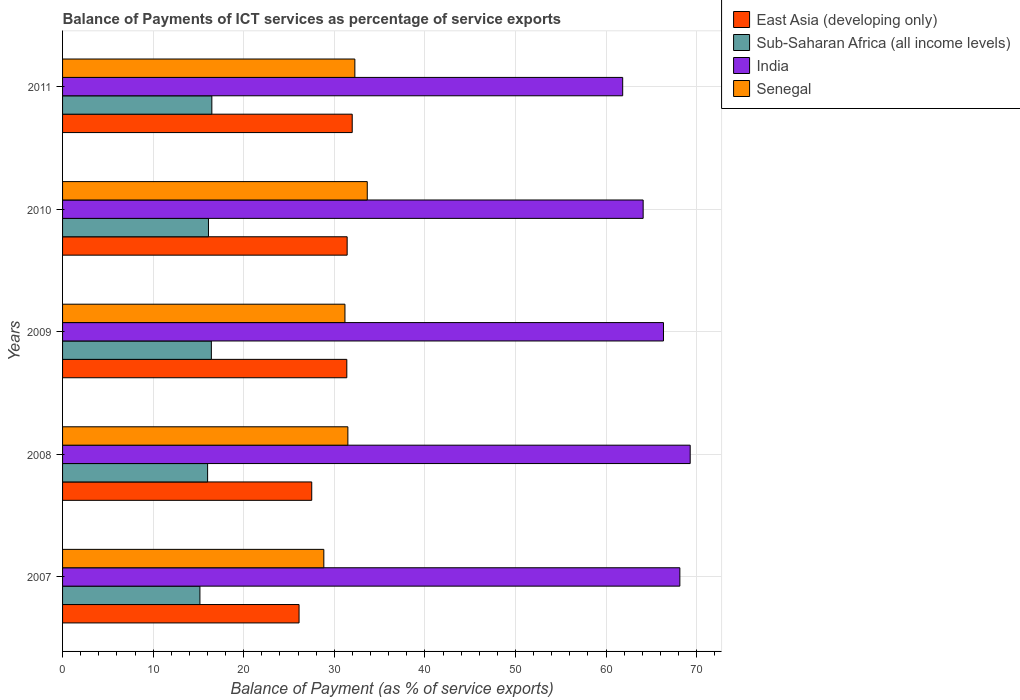How many different coloured bars are there?
Provide a succinct answer. 4. Are the number of bars per tick equal to the number of legend labels?
Offer a very short reply. Yes. How many bars are there on the 2nd tick from the top?
Provide a succinct answer. 4. What is the balance of payments of ICT services in East Asia (developing only) in 2007?
Keep it short and to the point. 26.11. Across all years, what is the maximum balance of payments of ICT services in India?
Your answer should be very brief. 69.29. Across all years, what is the minimum balance of payments of ICT services in East Asia (developing only)?
Provide a succinct answer. 26.11. In which year was the balance of payments of ICT services in India maximum?
Provide a short and direct response. 2008. What is the total balance of payments of ICT services in Sub-Saharan Africa (all income levels) in the graph?
Ensure brevity in your answer.  80.19. What is the difference between the balance of payments of ICT services in Senegal in 2008 and that in 2011?
Provide a succinct answer. -0.77. What is the difference between the balance of payments of ICT services in Sub-Saharan Africa (all income levels) in 2010 and the balance of payments of ICT services in India in 2009?
Ensure brevity in your answer.  -50.23. What is the average balance of payments of ICT services in Senegal per year?
Your answer should be very brief. 31.49. In the year 2011, what is the difference between the balance of payments of ICT services in India and balance of payments of ICT services in Sub-Saharan Africa (all income levels)?
Ensure brevity in your answer.  45.36. In how many years, is the balance of payments of ICT services in Senegal greater than 40 %?
Your answer should be compact. 0. What is the ratio of the balance of payments of ICT services in East Asia (developing only) in 2007 to that in 2011?
Provide a succinct answer. 0.82. Is the balance of payments of ICT services in Senegal in 2007 less than that in 2009?
Offer a very short reply. Yes. What is the difference between the highest and the second highest balance of payments of ICT services in Senegal?
Ensure brevity in your answer.  1.37. What is the difference between the highest and the lowest balance of payments of ICT services in Senegal?
Provide a succinct answer. 4.8. Is the sum of the balance of payments of ICT services in India in 2007 and 2010 greater than the maximum balance of payments of ICT services in Sub-Saharan Africa (all income levels) across all years?
Give a very brief answer. Yes. What does the 4th bar from the top in 2010 represents?
Ensure brevity in your answer.  East Asia (developing only). What does the 1st bar from the bottom in 2011 represents?
Provide a short and direct response. East Asia (developing only). Is it the case that in every year, the sum of the balance of payments of ICT services in Senegal and balance of payments of ICT services in East Asia (developing only) is greater than the balance of payments of ICT services in India?
Offer a terse response. No. How many years are there in the graph?
Provide a succinct answer. 5. Are the values on the major ticks of X-axis written in scientific E-notation?
Offer a terse response. No. Where does the legend appear in the graph?
Keep it short and to the point. Top right. How are the legend labels stacked?
Your answer should be compact. Vertical. What is the title of the graph?
Provide a succinct answer. Balance of Payments of ICT services as percentage of service exports. What is the label or title of the X-axis?
Your response must be concise. Balance of Payment (as % of service exports). What is the Balance of Payment (as % of service exports) of East Asia (developing only) in 2007?
Provide a succinct answer. 26.11. What is the Balance of Payment (as % of service exports) in Sub-Saharan Africa (all income levels) in 2007?
Keep it short and to the point. 15.16. What is the Balance of Payment (as % of service exports) of India in 2007?
Ensure brevity in your answer.  68.15. What is the Balance of Payment (as % of service exports) in Senegal in 2007?
Keep it short and to the point. 28.84. What is the Balance of Payment (as % of service exports) of East Asia (developing only) in 2008?
Your response must be concise. 27.51. What is the Balance of Payment (as % of service exports) in Sub-Saharan Africa (all income levels) in 2008?
Your answer should be compact. 16.01. What is the Balance of Payment (as % of service exports) in India in 2008?
Offer a very short reply. 69.29. What is the Balance of Payment (as % of service exports) of Senegal in 2008?
Offer a terse response. 31.5. What is the Balance of Payment (as % of service exports) of East Asia (developing only) in 2009?
Give a very brief answer. 31.38. What is the Balance of Payment (as % of service exports) of Sub-Saharan Africa (all income levels) in 2009?
Provide a succinct answer. 16.43. What is the Balance of Payment (as % of service exports) of India in 2009?
Provide a short and direct response. 66.34. What is the Balance of Payment (as % of service exports) in Senegal in 2009?
Ensure brevity in your answer.  31.18. What is the Balance of Payment (as % of service exports) in East Asia (developing only) in 2010?
Provide a short and direct response. 31.42. What is the Balance of Payment (as % of service exports) of Sub-Saharan Africa (all income levels) in 2010?
Ensure brevity in your answer.  16.11. What is the Balance of Payment (as % of service exports) of India in 2010?
Your answer should be compact. 64.1. What is the Balance of Payment (as % of service exports) in Senegal in 2010?
Keep it short and to the point. 33.64. What is the Balance of Payment (as % of service exports) of East Asia (developing only) in 2011?
Ensure brevity in your answer.  31.98. What is the Balance of Payment (as % of service exports) in Sub-Saharan Africa (all income levels) in 2011?
Make the answer very short. 16.48. What is the Balance of Payment (as % of service exports) of India in 2011?
Your answer should be compact. 61.84. What is the Balance of Payment (as % of service exports) in Senegal in 2011?
Your answer should be very brief. 32.27. Across all years, what is the maximum Balance of Payment (as % of service exports) in East Asia (developing only)?
Make the answer very short. 31.98. Across all years, what is the maximum Balance of Payment (as % of service exports) of Sub-Saharan Africa (all income levels)?
Your response must be concise. 16.48. Across all years, what is the maximum Balance of Payment (as % of service exports) of India?
Make the answer very short. 69.29. Across all years, what is the maximum Balance of Payment (as % of service exports) of Senegal?
Provide a succinct answer. 33.64. Across all years, what is the minimum Balance of Payment (as % of service exports) in East Asia (developing only)?
Provide a short and direct response. 26.11. Across all years, what is the minimum Balance of Payment (as % of service exports) in Sub-Saharan Africa (all income levels)?
Offer a terse response. 15.16. Across all years, what is the minimum Balance of Payment (as % of service exports) in India?
Keep it short and to the point. 61.84. Across all years, what is the minimum Balance of Payment (as % of service exports) in Senegal?
Keep it short and to the point. 28.84. What is the total Balance of Payment (as % of service exports) in East Asia (developing only) in the graph?
Your answer should be compact. 148.39. What is the total Balance of Payment (as % of service exports) of Sub-Saharan Africa (all income levels) in the graph?
Ensure brevity in your answer.  80.19. What is the total Balance of Payment (as % of service exports) of India in the graph?
Offer a very short reply. 329.72. What is the total Balance of Payment (as % of service exports) in Senegal in the graph?
Offer a terse response. 157.43. What is the difference between the Balance of Payment (as % of service exports) of East Asia (developing only) in 2007 and that in 2008?
Give a very brief answer. -1.4. What is the difference between the Balance of Payment (as % of service exports) in Sub-Saharan Africa (all income levels) in 2007 and that in 2008?
Provide a succinct answer. -0.85. What is the difference between the Balance of Payment (as % of service exports) of India in 2007 and that in 2008?
Offer a very short reply. -1.14. What is the difference between the Balance of Payment (as % of service exports) in Senegal in 2007 and that in 2008?
Offer a terse response. -2.66. What is the difference between the Balance of Payment (as % of service exports) in East Asia (developing only) in 2007 and that in 2009?
Your answer should be very brief. -5.27. What is the difference between the Balance of Payment (as % of service exports) in Sub-Saharan Africa (all income levels) in 2007 and that in 2009?
Provide a succinct answer. -1.26. What is the difference between the Balance of Payment (as % of service exports) in India in 2007 and that in 2009?
Your response must be concise. 1.81. What is the difference between the Balance of Payment (as % of service exports) in Senegal in 2007 and that in 2009?
Provide a succinct answer. -2.33. What is the difference between the Balance of Payment (as % of service exports) in East Asia (developing only) in 2007 and that in 2010?
Your answer should be compact. -5.31. What is the difference between the Balance of Payment (as % of service exports) in Sub-Saharan Africa (all income levels) in 2007 and that in 2010?
Give a very brief answer. -0.95. What is the difference between the Balance of Payment (as % of service exports) of India in 2007 and that in 2010?
Your answer should be compact. 4.05. What is the difference between the Balance of Payment (as % of service exports) in Senegal in 2007 and that in 2010?
Offer a very short reply. -4.8. What is the difference between the Balance of Payment (as % of service exports) in East Asia (developing only) in 2007 and that in 2011?
Keep it short and to the point. -5.87. What is the difference between the Balance of Payment (as % of service exports) of Sub-Saharan Africa (all income levels) in 2007 and that in 2011?
Your answer should be compact. -1.32. What is the difference between the Balance of Payment (as % of service exports) in India in 2007 and that in 2011?
Keep it short and to the point. 6.31. What is the difference between the Balance of Payment (as % of service exports) of Senegal in 2007 and that in 2011?
Keep it short and to the point. -3.43. What is the difference between the Balance of Payment (as % of service exports) of East Asia (developing only) in 2008 and that in 2009?
Your answer should be very brief. -3.87. What is the difference between the Balance of Payment (as % of service exports) of Sub-Saharan Africa (all income levels) in 2008 and that in 2009?
Ensure brevity in your answer.  -0.41. What is the difference between the Balance of Payment (as % of service exports) in India in 2008 and that in 2009?
Provide a succinct answer. 2.95. What is the difference between the Balance of Payment (as % of service exports) in Senegal in 2008 and that in 2009?
Your answer should be very brief. 0.32. What is the difference between the Balance of Payment (as % of service exports) of East Asia (developing only) in 2008 and that in 2010?
Offer a terse response. -3.91. What is the difference between the Balance of Payment (as % of service exports) in Sub-Saharan Africa (all income levels) in 2008 and that in 2010?
Provide a short and direct response. -0.09. What is the difference between the Balance of Payment (as % of service exports) in India in 2008 and that in 2010?
Your answer should be very brief. 5.19. What is the difference between the Balance of Payment (as % of service exports) of Senegal in 2008 and that in 2010?
Make the answer very short. -2.14. What is the difference between the Balance of Payment (as % of service exports) in East Asia (developing only) in 2008 and that in 2011?
Ensure brevity in your answer.  -4.47. What is the difference between the Balance of Payment (as % of service exports) of Sub-Saharan Africa (all income levels) in 2008 and that in 2011?
Give a very brief answer. -0.47. What is the difference between the Balance of Payment (as % of service exports) in India in 2008 and that in 2011?
Provide a short and direct response. 7.45. What is the difference between the Balance of Payment (as % of service exports) in Senegal in 2008 and that in 2011?
Keep it short and to the point. -0.77. What is the difference between the Balance of Payment (as % of service exports) in East Asia (developing only) in 2009 and that in 2010?
Provide a succinct answer. -0.04. What is the difference between the Balance of Payment (as % of service exports) of Sub-Saharan Africa (all income levels) in 2009 and that in 2010?
Offer a very short reply. 0.32. What is the difference between the Balance of Payment (as % of service exports) of India in 2009 and that in 2010?
Offer a terse response. 2.24. What is the difference between the Balance of Payment (as % of service exports) of Senegal in 2009 and that in 2010?
Your answer should be compact. -2.46. What is the difference between the Balance of Payment (as % of service exports) in East Asia (developing only) in 2009 and that in 2011?
Provide a short and direct response. -0.6. What is the difference between the Balance of Payment (as % of service exports) of Sub-Saharan Africa (all income levels) in 2009 and that in 2011?
Give a very brief answer. -0.05. What is the difference between the Balance of Payment (as % of service exports) of India in 2009 and that in 2011?
Ensure brevity in your answer.  4.5. What is the difference between the Balance of Payment (as % of service exports) of Senegal in 2009 and that in 2011?
Offer a very short reply. -1.09. What is the difference between the Balance of Payment (as % of service exports) of East Asia (developing only) in 2010 and that in 2011?
Offer a very short reply. -0.56. What is the difference between the Balance of Payment (as % of service exports) of Sub-Saharan Africa (all income levels) in 2010 and that in 2011?
Keep it short and to the point. -0.37. What is the difference between the Balance of Payment (as % of service exports) of India in 2010 and that in 2011?
Give a very brief answer. 2.26. What is the difference between the Balance of Payment (as % of service exports) in Senegal in 2010 and that in 2011?
Provide a succinct answer. 1.37. What is the difference between the Balance of Payment (as % of service exports) in East Asia (developing only) in 2007 and the Balance of Payment (as % of service exports) in Sub-Saharan Africa (all income levels) in 2008?
Give a very brief answer. 10.1. What is the difference between the Balance of Payment (as % of service exports) of East Asia (developing only) in 2007 and the Balance of Payment (as % of service exports) of India in 2008?
Your answer should be very brief. -43.18. What is the difference between the Balance of Payment (as % of service exports) in East Asia (developing only) in 2007 and the Balance of Payment (as % of service exports) in Senegal in 2008?
Provide a short and direct response. -5.39. What is the difference between the Balance of Payment (as % of service exports) in Sub-Saharan Africa (all income levels) in 2007 and the Balance of Payment (as % of service exports) in India in 2008?
Offer a very short reply. -54.13. What is the difference between the Balance of Payment (as % of service exports) in Sub-Saharan Africa (all income levels) in 2007 and the Balance of Payment (as % of service exports) in Senegal in 2008?
Your answer should be compact. -16.34. What is the difference between the Balance of Payment (as % of service exports) in India in 2007 and the Balance of Payment (as % of service exports) in Senegal in 2008?
Make the answer very short. 36.65. What is the difference between the Balance of Payment (as % of service exports) in East Asia (developing only) in 2007 and the Balance of Payment (as % of service exports) in Sub-Saharan Africa (all income levels) in 2009?
Offer a terse response. 9.68. What is the difference between the Balance of Payment (as % of service exports) in East Asia (developing only) in 2007 and the Balance of Payment (as % of service exports) in India in 2009?
Provide a short and direct response. -40.23. What is the difference between the Balance of Payment (as % of service exports) of East Asia (developing only) in 2007 and the Balance of Payment (as % of service exports) of Senegal in 2009?
Provide a succinct answer. -5.07. What is the difference between the Balance of Payment (as % of service exports) in Sub-Saharan Africa (all income levels) in 2007 and the Balance of Payment (as % of service exports) in India in 2009?
Provide a short and direct response. -51.18. What is the difference between the Balance of Payment (as % of service exports) in Sub-Saharan Africa (all income levels) in 2007 and the Balance of Payment (as % of service exports) in Senegal in 2009?
Your answer should be very brief. -16.01. What is the difference between the Balance of Payment (as % of service exports) in India in 2007 and the Balance of Payment (as % of service exports) in Senegal in 2009?
Offer a very short reply. 36.97. What is the difference between the Balance of Payment (as % of service exports) of East Asia (developing only) in 2007 and the Balance of Payment (as % of service exports) of Sub-Saharan Africa (all income levels) in 2010?
Provide a short and direct response. 10. What is the difference between the Balance of Payment (as % of service exports) in East Asia (developing only) in 2007 and the Balance of Payment (as % of service exports) in India in 2010?
Offer a terse response. -37.99. What is the difference between the Balance of Payment (as % of service exports) in East Asia (developing only) in 2007 and the Balance of Payment (as % of service exports) in Senegal in 2010?
Offer a terse response. -7.53. What is the difference between the Balance of Payment (as % of service exports) of Sub-Saharan Africa (all income levels) in 2007 and the Balance of Payment (as % of service exports) of India in 2010?
Your answer should be very brief. -48.93. What is the difference between the Balance of Payment (as % of service exports) of Sub-Saharan Africa (all income levels) in 2007 and the Balance of Payment (as % of service exports) of Senegal in 2010?
Ensure brevity in your answer.  -18.48. What is the difference between the Balance of Payment (as % of service exports) of India in 2007 and the Balance of Payment (as % of service exports) of Senegal in 2010?
Give a very brief answer. 34.51. What is the difference between the Balance of Payment (as % of service exports) of East Asia (developing only) in 2007 and the Balance of Payment (as % of service exports) of Sub-Saharan Africa (all income levels) in 2011?
Your response must be concise. 9.63. What is the difference between the Balance of Payment (as % of service exports) in East Asia (developing only) in 2007 and the Balance of Payment (as % of service exports) in India in 2011?
Offer a terse response. -35.73. What is the difference between the Balance of Payment (as % of service exports) in East Asia (developing only) in 2007 and the Balance of Payment (as % of service exports) in Senegal in 2011?
Your answer should be very brief. -6.16. What is the difference between the Balance of Payment (as % of service exports) of Sub-Saharan Africa (all income levels) in 2007 and the Balance of Payment (as % of service exports) of India in 2011?
Ensure brevity in your answer.  -46.67. What is the difference between the Balance of Payment (as % of service exports) of Sub-Saharan Africa (all income levels) in 2007 and the Balance of Payment (as % of service exports) of Senegal in 2011?
Your answer should be compact. -17.11. What is the difference between the Balance of Payment (as % of service exports) of India in 2007 and the Balance of Payment (as % of service exports) of Senegal in 2011?
Your response must be concise. 35.88. What is the difference between the Balance of Payment (as % of service exports) of East Asia (developing only) in 2008 and the Balance of Payment (as % of service exports) of Sub-Saharan Africa (all income levels) in 2009?
Make the answer very short. 11.08. What is the difference between the Balance of Payment (as % of service exports) of East Asia (developing only) in 2008 and the Balance of Payment (as % of service exports) of India in 2009?
Make the answer very short. -38.83. What is the difference between the Balance of Payment (as % of service exports) of East Asia (developing only) in 2008 and the Balance of Payment (as % of service exports) of Senegal in 2009?
Give a very brief answer. -3.67. What is the difference between the Balance of Payment (as % of service exports) in Sub-Saharan Africa (all income levels) in 2008 and the Balance of Payment (as % of service exports) in India in 2009?
Make the answer very short. -50.33. What is the difference between the Balance of Payment (as % of service exports) of Sub-Saharan Africa (all income levels) in 2008 and the Balance of Payment (as % of service exports) of Senegal in 2009?
Your answer should be compact. -15.16. What is the difference between the Balance of Payment (as % of service exports) of India in 2008 and the Balance of Payment (as % of service exports) of Senegal in 2009?
Provide a succinct answer. 38.11. What is the difference between the Balance of Payment (as % of service exports) in East Asia (developing only) in 2008 and the Balance of Payment (as % of service exports) in Sub-Saharan Africa (all income levels) in 2010?
Give a very brief answer. 11.4. What is the difference between the Balance of Payment (as % of service exports) of East Asia (developing only) in 2008 and the Balance of Payment (as % of service exports) of India in 2010?
Keep it short and to the point. -36.59. What is the difference between the Balance of Payment (as % of service exports) of East Asia (developing only) in 2008 and the Balance of Payment (as % of service exports) of Senegal in 2010?
Offer a terse response. -6.13. What is the difference between the Balance of Payment (as % of service exports) of Sub-Saharan Africa (all income levels) in 2008 and the Balance of Payment (as % of service exports) of India in 2010?
Provide a short and direct response. -48.08. What is the difference between the Balance of Payment (as % of service exports) in Sub-Saharan Africa (all income levels) in 2008 and the Balance of Payment (as % of service exports) in Senegal in 2010?
Offer a very short reply. -17.63. What is the difference between the Balance of Payment (as % of service exports) of India in 2008 and the Balance of Payment (as % of service exports) of Senegal in 2010?
Offer a terse response. 35.65. What is the difference between the Balance of Payment (as % of service exports) in East Asia (developing only) in 2008 and the Balance of Payment (as % of service exports) in Sub-Saharan Africa (all income levels) in 2011?
Your response must be concise. 11.03. What is the difference between the Balance of Payment (as % of service exports) in East Asia (developing only) in 2008 and the Balance of Payment (as % of service exports) in India in 2011?
Provide a short and direct response. -34.33. What is the difference between the Balance of Payment (as % of service exports) in East Asia (developing only) in 2008 and the Balance of Payment (as % of service exports) in Senegal in 2011?
Offer a terse response. -4.76. What is the difference between the Balance of Payment (as % of service exports) in Sub-Saharan Africa (all income levels) in 2008 and the Balance of Payment (as % of service exports) in India in 2011?
Make the answer very short. -45.82. What is the difference between the Balance of Payment (as % of service exports) of Sub-Saharan Africa (all income levels) in 2008 and the Balance of Payment (as % of service exports) of Senegal in 2011?
Provide a short and direct response. -16.25. What is the difference between the Balance of Payment (as % of service exports) in India in 2008 and the Balance of Payment (as % of service exports) in Senegal in 2011?
Ensure brevity in your answer.  37.02. What is the difference between the Balance of Payment (as % of service exports) in East Asia (developing only) in 2009 and the Balance of Payment (as % of service exports) in Sub-Saharan Africa (all income levels) in 2010?
Offer a terse response. 15.27. What is the difference between the Balance of Payment (as % of service exports) in East Asia (developing only) in 2009 and the Balance of Payment (as % of service exports) in India in 2010?
Keep it short and to the point. -32.72. What is the difference between the Balance of Payment (as % of service exports) of East Asia (developing only) in 2009 and the Balance of Payment (as % of service exports) of Senegal in 2010?
Your answer should be very brief. -2.26. What is the difference between the Balance of Payment (as % of service exports) in Sub-Saharan Africa (all income levels) in 2009 and the Balance of Payment (as % of service exports) in India in 2010?
Your answer should be very brief. -47.67. What is the difference between the Balance of Payment (as % of service exports) in Sub-Saharan Africa (all income levels) in 2009 and the Balance of Payment (as % of service exports) in Senegal in 2010?
Make the answer very short. -17.21. What is the difference between the Balance of Payment (as % of service exports) in India in 2009 and the Balance of Payment (as % of service exports) in Senegal in 2010?
Offer a very short reply. 32.7. What is the difference between the Balance of Payment (as % of service exports) in East Asia (developing only) in 2009 and the Balance of Payment (as % of service exports) in Sub-Saharan Africa (all income levels) in 2011?
Provide a succinct answer. 14.9. What is the difference between the Balance of Payment (as % of service exports) of East Asia (developing only) in 2009 and the Balance of Payment (as % of service exports) of India in 2011?
Give a very brief answer. -30.46. What is the difference between the Balance of Payment (as % of service exports) in East Asia (developing only) in 2009 and the Balance of Payment (as % of service exports) in Senegal in 2011?
Give a very brief answer. -0.89. What is the difference between the Balance of Payment (as % of service exports) in Sub-Saharan Africa (all income levels) in 2009 and the Balance of Payment (as % of service exports) in India in 2011?
Your answer should be compact. -45.41. What is the difference between the Balance of Payment (as % of service exports) in Sub-Saharan Africa (all income levels) in 2009 and the Balance of Payment (as % of service exports) in Senegal in 2011?
Provide a succinct answer. -15.84. What is the difference between the Balance of Payment (as % of service exports) in India in 2009 and the Balance of Payment (as % of service exports) in Senegal in 2011?
Your response must be concise. 34.07. What is the difference between the Balance of Payment (as % of service exports) in East Asia (developing only) in 2010 and the Balance of Payment (as % of service exports) in Sub-Saharan Africa (all income levels) in 2011?
Keep it short and to the point. 14.94. What is the difference between the Balance of Payment (as % of service exports) of East Asia (developing only) in 2010 and the Balance of Payment (as % of service exports) of India in 2011?
Offer a very short reply. -30.42. What is the difference between the Balance of Payment (as % of service exports) in East Asia (developing only) in 2010 and the Balance of Payment (as % of service exports) in Senegal in 2011?
Your answer should be very brief. -0.85. What is the difference between the Balance of Payment (as % of service exports) of Sub-Saharan Africa (all income levels) in 2010 and the Balance of Payment (as % of service exports) of India in 2011?
Offer a terse response. -45.73. What is the difference between the Balance of Payment (as % of service exports) of Sub-Saharan Africa (all income levels) in 2010 and the Balance of Payment (as % of service exports) of Senegal in 2011?
Give a very brief answer. -16.16. What is the difference between the Balance of Payment (as % of service exports) in India in 2010 and the Balance of Payment (as % of service exports) in Senegal in 2011?
Provide a succinct answer. 31.83. What is the average Balance of Payment (as % of service exports) of East Asia (developing only) per year?
Provide a succinct answer. 29.68. What is the average Balance of Payment (as % of service exports) of Sub-Saharan Africa (all income levels) per year?
Ensure brevity in your answer.  16.04. What is the average Balance of Payment (as % of service exports) of India per year?
Your answer should be very brief. 65.94. What is the average Balance of Payment (as % of service exports) in Senegal per year?
Your response must be concise. 31.49. In the year 2007, what is the difference between the Balance of Payment (as % of service exports) in East Asia (developing only) and Balance of Payment (as % of service exports) in Sub-Saharan Africa (all income levels)?
Your response must be concise. 10.95. In the year 2007, what is the difference between the Balance of Payment (as % of service exports) in East Asia (developing only) and Balance of Payment (as % of service exports) in India?
Ensure brevity in your answer.  -42.04. In the year 2007, what is the difference between the Balance of Payment (as % of service exports) of East Asia (developing only) and Balance of Payment (as % of service exports) of Senegal?
Ensure brevity in your answer.  -2.73. In the year 2007, what is the difference between the Balance of Payment (as % of service exports) in Sub-Saharan Africa (all income levels) and Balance of Payment (as % of service exports) in India?
Your answer should be very brief. -52.99. In the year 2007, what is the difference between the Balance of Payment (as % of service exports) in Sub-Saharan Africa (all income levels) and Balance of Payment (as % of service exports) in Senegal?
Give a very brief answer. -13.68. In the year 2007, what is the difference between the Balance of Payment (as % of service exports) of India and Balance of Payment (as % of service exports) of Senegal?
Ensure brevity in your answer.  39.31. In the year 2008, what is the difference between the Balance of Payment (as % of service exports) in East Asia (developing only) and Balance of Payment (as % of service exports) in Sub-Saharan Africa (all income levels)?
Provide a succinct answer. 11.49. In the year 2008, what is the difference between the Balance of Payment (as % of service exports) of East Asia (developing only) and Balance of Payment (as % of service exports) of India?
Offer a terse response. -41.78. In the year 2008, what is the difference between the Balance of Payment (as % of service exports) of East Asia (developing only) and Balance of Payment (as % of service exports) of Senegal?
Keep it short and to the point. -3.99. In the year 2008, what is the difference between the Balance of Payment (as % of service exports) of Sub-Saharan Africa (all income levels) and Balance of Payment (as % of service exports) of India?
Offer a very short reply. -53.28. In the year 2008, what is the difference between the Balance of Payment (as % of service exports) in Sub-Saharan Africa (all income levels) and Balance of Payment (as % of service exports) in Senegal?
Make the answer very short. -15.48. In the year 2008, what is the difference between the Balance of Payment (as % of service exports) of India and Balance of Payment (as % of service exports) of Senegal?
Make the answer very short. 37.79. In the year 2009, what is the difference between the Balance of Payment (as % of service exports) of East Asia (developing only) and Balance of Payment (as % of service exports) of Sub-Saharan Africa (all income levels)?
Ensure brevity in your answer.  14.95. In the year 2009, what is the difference between the Balance of Payment (as % of service exports) in East Asia (developing only) and Balance of Payment (as % of service exports) in India?
Ensure brevity in your answer.  -34.96. In the year 2009, what is the difference between the Balance of Payment (as % of service exports) in East Asia (developing only) and Balance of Payment (as % of service exports) in Senegal?
Give a very brief answer. 0.21. In the year 2009, what is the difference between the Balance of Payment (as % of service exports) of Sub-Saharan Africa (all income levels) and Balance of Payment (as % of service exports) of India?
Provide a succinct answer. -49.91. In the year 2009, what is the difference between the Balance of Payment (as % of service exports) of Sub-Saharan Africa (all income levels) and Balance of Payment (as % of service exports) of Senegal?
Provide a succinct answer. -14.75. In the year 2009, what is the difference between the Balance of Payment (as % of service exports) in India and Balance of Payment (as % of service exports) in Senegal?
Provide a short and direct response. 35.17. In the year 2010, what is the difference between the Balance of Payment (as % of service exports) of East Asia (developing only) and Balance of Payment (as % of service exports) of Sub-Saharan Africa (all income levels)?
Offer a terse response. 15.31. In the year 2010, what is the difference between the Balance of Payment (as % of service exports) of East Asia (developing only) and Balance of Payment (as % of service exports) of India?
Your answer should be very brief. -32.68. In the year 2010, what is the difference between the Balance of Payment (as % of service exports) of East Asia (developing only) and Balance of Payment (as % of service exports) of Senegal?
Your answer should be very brief. -2.22. In the year 2010, what is the difference between the Balance of Payment (as % of service exports) in Sub-Saharan Africa (all income levels) and Balance of Payment (as % of service exports) in India?
Your answer should be very brief. -47.99. In the year 2010, what is the difference between the Balance of Payment (as % of service exports) of Sub-Saharan Africa (all income levels) and Balance of Payment (as % of service exports) of Senegal?
Offer a terse response. -17.53. In the year 2010, what is the difference between the Balance of Payment (as % of service exports) in India and Balance of Payment (as % of service exports) in Senegal?
Keep it short and to the point. 30.46. In the year 2011, what is the difference between the Balance of Payment (as % of service exports) of East Asia (developing only) and Balance of Payment (as % of service exports) of Sub-Saharan Africa (all income levels)?
Provide a succinct answer. 15.5. In the year 2011, what is the difference between the Balance of Payment (as % of service exports) in East Asia (developing only) and Balance of Payment (as % of service exports) in India?
Offer a very short reply. -29.86. In the year 2011, what is the difference between the Balance of Payment (as % of service exports) of East Asia (developing only) and Balance of Payment (as % of service exports) of Senegal?
Offer a terse response. -0.29. In the year 2011, what is the difference between the Balance of Payment (as % of service exports) in Sub-Saharan Africa (all income levels) and Balance of Payment (as % of service exports) in India?
Keep it short and to the point. -45.36. In the year 2011, what is the difference between the Balance of Payment (as % of service exports) of Sub-Saharan Africa (all income levels) and Balance of Payment (as % of service exports) of Senegal?
Offer a very short reply. -15.79. In the year 2011, what is the difference between the Balance of Payment (as % of service exports) of India and Balance of Payment (as % of service exports) of Senegal?
Ensure brevity in your answer.  29.57. What is the ratio of the Balance of Payment (as % of service exports) in East Asia (developing only) in 2007 to that in 2008?
Make the answer very short. 0.95. What is the ratio of the Balance of Payment (as % of service exports) of Sub-Saharan Africa (all income levels) in 2007 to that in 2008?
Your answer should be compact. 0.95. What is the ratio of the Balance of Payment (as % of service exports) of India in 2007 to that in 2008?
Ensure brevity in your answer.  0.98. What is the ratio of the Balance of Payment (as % of service exports) in Senegal in 2007 to that in 2008?
Give a very brief answer. 0.92. What is the ratio of the Balance of Payment (as % of service exports) of East Asia (developing only) in 2007 to that in 2009?
Keep it short and to the point. 0.83. What is the ratio of the Balance of Payment (as % of service exports) of Sub-Saharan Africa (all income levels) in 2007 to that in 2009?
Your answer should be very brief. 0.92. What is the ratio of the Balance of Payment (as % of service exports) of India in 2007 to that in 2009?
Keep it short and to the point. 1.03. What is the ratio of the Balance of Payment (as % of service exports) of Senegal in 2007 to that in 2009?
Your answer should be very brief. 0.93. What is the ratio of the Balance of Payment (as % of service exports) in East Asia (developing only) in 2007 to that in 2010?
Your response must be concise. 0.83. What is the ratio of the Balance of Payment (as % of service exports) in Sub-Saharan Africa (all income levels) in 2007 to that in 2010?
Ensure brevity in your answer.  0.94. What is the ratio of the Balance of Payment (as % of service exports) in India in 2007 to that in 2010?
Your answer should be compact. 1.06. What is the ratio of the Balance of Payment (as % of service exports) of Senegal in 2007 to that in 2010?
Offer a very short reply. 0.86. What is the ratio of the Balance of Payment (as % of service exports) of East Asia (developing only) in 2007 to that in 2011?
Offer a very short reply. 0.82. What is the ratio of the Balance of Payment (as % of service exports) of Sub-Saharan Africa (all income levels) in 2007 to that in 2011?
Provide a succinct answer. 0.92. What is the ratio of the Balance of Payment (as % of service exports) of India in 2007 to that in 2011?
Your answer should be compact. 1.1. What is the ratio of the Balance of Payment (as % of service exports) of Senegal in 2007 to that in 2011?
Keep it short and to the point. 0.89. What is the ratio of the Balance of Payment (as % of service exports) in East Asia (developing only) in 2008 to that in 2009?
Offer a terse response. 0.88. What is the ratio of the Balance of Payment (as % of service exports) in Sub-Saharan Africa (all income levels) in 2008 to that in 2009?
Provide a short and direct response. 0.97. What is the ratio of the Balance of Payment (as % of service exports) of India in 2008 to that in 2009?
Give a very brief answer. 1.04. What is the ratio of the Balance of Payment (as % of service exports) of Senegal in 2008 to that in 2009?
Your answer should be compact. 1.01. What is the ratio of the Balance of Payment (as % of service exports) of East Asia (developing only) in 2008 to that in 2010?
Give a very brief answer. 0.88. What is the ratio of the Balance of Payment (as % of service exports) in India in 2008 to that in 2010?
Make the answer very short. 1.08. What is the ratio of the Balance of Payment (as % of service exports) of Senegal in 2008 to that in 2010?
Make the answer very short. 0.94. What is the ratio of the Balance of Payment (as % of service exports) of East Asia (developing only) in 2008 to that in 2011?
Provide a succinct answer. 0.86. What is the ratio of the Balance of Payment (as % of service exports) of Sub-Saharan Africa (all income levels) in 2008 to that in 2011?
Make the answer very short. 0.97. What is the ratio of the Balance of Payment (as % of service exports) of India in 2008 to that in 2011?
Provide a short and direct response. 1.12. What is the ratio of the Balance of Payment (as % of service exports) of Senegal in 2008 to that in 2011?
Provide a short and direct response. 0.98. What is the ratio of the Balance of Payment (as % of service exports) in Sub-Saharan Africa (all income levels) in 2009 to that in 2010?
Make the answer very short. 1.02. What is the ratio of the Balance of Payment (as % of service exports) of India in 2009 to that in 2010?
Provide a short and direct response. 1.03. What is the ratio of the Balance of Payment (as % of service exports) in Senegal in 2009 to that in 2010?
Offer a terse response. 0.93. What is the ratio of the Balance of Payment (as % of service exports) in East Asia (developing only) in 2009 to that in 2011?
Your response must be concise. 0.98. What is the ratio of the Balance of Payment (as % of service exports) of Sub-Saharan Africa (all income levels) in 2009 to that in 2011?
Give a very brief answer. 1. What is the ratio of the Balance of Payment (as % of service exports) of India in 2009 to that in 2011?
Keep it short and to the point. 1.07. What is the ratio of the Balance of Payment (as % of service exports) in Senegal in 2009 to that in 2011?
Make the answer very short. 0.97. What is the ratio of the Balance of Payment (as % of service exports) of East Asia (developing only) in 2010 to that in 2011?
Ensure brevity in your answer.  0.98. What is the ratio of the Balance of Payment (as % of service exports) of Sub-Saharan Africa (all income levels) in 2010 to that in 2011?
Provide a short and direct response. 0.98. What is the ratio of the Balance of Payment (as % of service exports) in India in 2010 to that in 2011?
Your response must be concise. 1.04. What is the ratio of the Balance of Payment (as % of service exports) in Senegal in 2010 to that in 2011?
Keep it short and to the point. 1.04. What is the difference between the highest and the second highest Balance of Payment (as % of service exports) of East Asia (developing only)?
Provide a short and direct response. 0.56. What is the difference between the highest and the second highest Balance of Payment (as % of service exports) of Sub-Saharan Africa (all income levels)?
Your answer should be compact. 0.05. What is the difference between the highest and the second highest Balance of Payment (as % of service exports) in India?
Your answer should be compact. 1.14. What is the difference between the highest and the second highest Balance of Payment (as % of service exports) in Senegal?
Your answer should be compact. 1.37. What is the difference between the highest and the lowest Balance of Payment (as % of service exports) of East Asia (developing only)?
Offer a very short reply. 5.87. What is the difference between the highest and the lowest Balance of Payment (as % of service exports) in Sub-Saharan Africa (all income levels)?
Your answer should be compact. 1.32. What is the difference between the highest and the lowest Balance of Payment (as % of service exports) of India?
Offer a very short reply. 7.45. What is the difference between the highest and the lowest Balance of Payment (as % of service exports) of Senegal?
Provide a succinct answer. 4.8. 